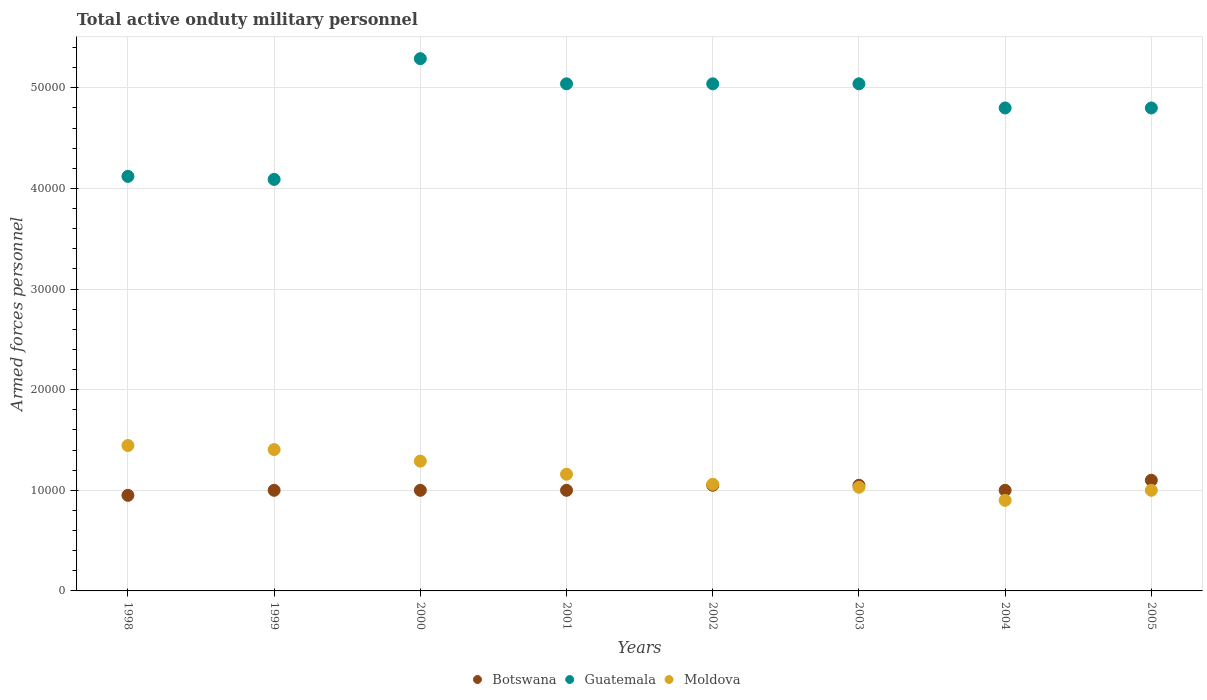What is the number of armed forces personnel in Moldova in 2002?
Your answer should be compact. 1.06e+04. Across all years, what is the maximum number of armed forces personnel in Guatemala?
Make the answer very short. 5.29e+04. Across all years, what is the minimum number of armed forces personnel in Botswana?
Provide a short and direct response. 9500. In which year was the number of armed forces personnel in Moldova maximum?
Provide a short and direct response. 1998. In which year was the number of armed forces personnel in Botswana minimum?
Your answer should be compact. 1998. What is the total number of armed forces personnel in Moldova in the graph?
Keep it short and to the point. 9.29e+04. What is the difference between the number of armed forces personnel in Moldova in 1999 and that in 2002?
Ensure brevity in your answer.  3450. What is the difference between the number of armed forces personnel in Moldova in 1998 and the number of armed forces personnel in Guatemala in 1999?
Provide a succinct answer. -2.64e+04. What is the average number of armed forces personnel in Guatemala per year?
Your response must be concise. 4.78e+04. In how many years, is the number of armed forces personnel in Botswana greater than 6000?
Your answer should be very brief. 8. What is the ratio of the number of armed forces personnel in Moldova in 2001 to that in 2004?
Give a very brief answer. 1.29. What is the difference between the highest and the second highest number of armed forces personnel in Guatemala?
Offer a terse response. 2500. What is the difference between the highest and the lowest number of armed forces personnel in Moldova?
Give a very brief answer. 5450. Is the sum of the number of armed forces personnel in Guatemala in 2003 and 2004 greater than the maximum number of armed forces personnel in Moldova across all years?
Make the answer very short. Yes. Is it the case that in every year, the sum of the number of armed forces personnel in Botswana and number of armed forces personnel in Moldova  is greater than the number of armed forces personnel in Guatemala?
Your answer should be compact. No. Is the number of armed forces personnel in Moldova strictly less than the number of armed forces personnel in Guatemala over the years?
Provide a short and direct response. Yes. How many years are there in the graph?
Offer a very short reply. 8. What is the difference between two consecutive major ticks on the Y-axis?
Your answer should be very brief. 10000. Are the values on the major ticks of Y-axis written in scientific E-notation?
Your answer should be very brief. No. Does the graph contain any zero values?
Ensure brevity in your answer.  No. Does the graph contain grids?
Your answer should be very brief. Yes. Where does the legend appear in the graph?
Your response must be concise. Bottom center. How many legend labels are there?
Your answer should be compact. 3. What is the title of the graph?
Your answer should be very brief. Total active onduty military personnel. Does "Bahamas" appear as one of the legend labels in the graph?
Your answer should be very brief. No. What is the label or title of the X-axis?
Your answer should be compact. Years. What is the label or title of the Y-axis?
Your answer should be compact. Armed forces personnel. What is the Armed forces personnel in Botswana in 1998?
Give a very brief answer. 9500. What is the Armed forces personnel of Guatemala in 1998?
Offer a terse response. 4.12e+04. What is the Armed forces personnel of Moldova in 1998?
Ensure brevity in your answer.  1.44e+04. What is the Armed forces personnel of Botswana in 1999?
Offer a very short reply. 10000. What is the Armed forces personnel in Guatemala in 1999?
Provide a short and direct response. 4.09e+04. What is the Armed forces personnel in Moldova in 1999?
Your response must be concise. 1.40e+04. What is the Armed forces personnel in Botswana in 2000?
Make the answer very short. 10000. What is the Armed forces personnel in Guatemala in 2000?
Make the answer very short. 5.29e+04. What is the Armed forces personnel of Moldova in 2000?
Offer a terse response. 1.29e+04. What is the Armed forces personnel in Guatemala in 2001?
Offer a very short reply. 5.04e+04. What is the Armed forces personnel in Moldova in 2001?
Offer a terse response. 1.16e+04. What is the Armed forces personnel of Botswana in 2002?
Keep it short and to the point. 1.05e+04. What is the Armed forces personnel in Guatemala in 2002?
Make the answer very short. 5.04e+04. What is the Armed forces personnel in Moldova in 2002?
Give a very brief answer. 1.06e+04. What is the Armed forces personnel of Botswana in 2003?
Ensure brevity in your answer.  1.05e+04. What is the Armed forces personnel of Guatemala in 2003?
Make the answer very short. 5.04e+04. What is the Armed forces personnel of Moldova in 2003?
Make the answer very short. 1.03e+04. What is the Armed forces personnel of Botswana in 2004?
Your answer should be compact. 10000. What is the Armed forces personnel of Guatemala in 2004?
Give a very brief answer. 4.80e+04. What is the Armed forces personnel of Moldova in 2004?
Offer a terse response. 9000. What is the Armed forces personnel in Botswana in 2005?
Make the answer very short. 1.10e+04. What is the Armed forces personnel in Guatemala in 2005?
Your response must be concise. 4.80e+04. What is the Armed forces personnel in Moldova in 2005?
Ensure brevity in your answer.  10000. Across all years, what is the maximum Armed forces personnel in Botswana?
Your answer should be compact. 1.10e+04. Across all years, what is the maximum Armed forces personnel in Guatemala?
Keep it short and to the point. 5.29e+04. Across all years, what is the maximum Armed forces personnel of Moldova?
Your answer should be compact. 1.44e+04. Across all years, what is the minimum Armed forces personnel of Botswana?
Provide a succinct answer. 9500. Across all years, what is the minimum Armed forces personnel of Guatemala?
Your answer should be compact. 4.09e+04. Across all years, what is the minimum Armed forces personnel of Moldova?
Ensure brevity in your answer.  9000. What is the total Armed forces personnel of Botswana in the graph?
Provide a short and direct response. 8.15e+04. What is the total Armed forces personnel of Guatemala in the graph?
Your answer should be compact. 3.82e+05. What is the total Armed forces personnel of Moldova in the graph?
Your answer should be very brief. 9.29e+04. What is the difference between the Armed forces personnel in Botswana in 1998 and that in 1999?
Provide a short and direct response. -500. What is the difference between the Armed forces personnel of Guatemala in 1998 and that in 1999?
Offer a terse response. 300. What is the difference between the Armed forces personnel of Moldova in 1998 and that in 1999?
Keep it short and to the point. 400. What is the difference between the Armed forces personnel of Botswana in 1998 and that in 2000?
Offer a very short reply. -500. What is the difference between the Armed forces personnel of Guatemala in 1998 and that in 2000?
Keep it short and to the point. -1.17e+04. What is the difference between the Armed forces personnel of Moldova in 1998 and that in 2000?
Your answer should be compact. 1550. What is the difference between the Armed forces personnel in Botswana in 1998 and that in 2001?
Your response must be concise. -500. What is the difference between the Armed forces personnel in Guatemala in 1998 and that in 2001?
Give a very brief answer. -9200. What is the difference between the Armed forces personnel of Moldova in 1998 and that in 2001?
Offer a terse response. 2850. What is the difference between the Armed forces personnel of Botswana in 1998 and that in 2002?
Provide a short and direct response. -1000. What is the difference between the Armed forces personnel in Guatemala in 1998 and that in 2002?
Your answer should be very brief. -9200. What is the difference between the Armed forces personnel of Moldova in 1998 and that in 2002?
Your answer should be very brief. 3850. What is the difference between the Armed forces personnel of Botswana in 1998 and that in 2003?
Offer a very short reply. -1000. What is the difference between the Armed forces personnel in Guatemala in 1998 and that in 2003?
Offer a very short reply. -9200. What is the difference between the Armed forces personnel in Moldova in 1998 and that in 2003?
Ensure brevity in your answer.  4150. What is the difference between the Armed forces personnel in Botswana in 1998 and that in 2004?
Provide a succinct answer. -500. What is the difference between the Armed forces personnel in Guatemala in 1998 and that in 2004?
Your answer should be very brief. -6800. What is the difference between the Armed forces personnel of Moldova in 1998 and that in 2004?
Keep it short and to the point. 5450. What is the difference between the Armed forces personnel of Botswana in 1998 and that in 2005?
Make the answer very short. -1500. What is the difference between the Armed forces personnel of Guatemala in 1998 and that in 2005?
Make the answer very short. -6800. What is the difference between the Armed forces personnel of Moldova in 1998 and that in 2005?
Your answer should be very brief. 4450. What is the difference between the Armed forces personnel in Guatemala in 1999 and that in 2000?
Give a very brief answer. -1.20e+04. What is the difference between the Armed forces personnel in Moldova in 1999 and that in 2000?
Offer a terse response. 1150. What is the difference between the Armed forces personnel of Guatemala in 1999 and that in 2001?
Your answer should be compact. -9500. What is the difference between the Armed forces personnel of Moldova in 1999 and that in 2001?
Keep it short and to the point. 2450. What is the difference between the Armed forces personnel of Botswana in 1999 and that in 2002?
Provide a short and direct response. -500. What is the difference between the Armed forces personnel of Guatemala in 1999 and that in 2002?
Keep it short and to the point. -9500. What is the difference between the Armed forces personnel of Moldova in 1999 and that in 2002?
Offer a very short reply. 3450. What is the difference between the Armed forces personnel in Botswana in 1999 and that in 2003?
Your answer should be very brief. -500. What is the difference between the Armed forces personnel in Guatemala in 1999 and that in 2003?
Your response must be concise. -9500. What is the difference between the Armed forces personnel of Moldova in 1999 and that in 2003?
Offer a terse response. 3750. What is the difference between the Armed forces personnel of Botswana in 1999 and that in 2004?
Your response must be concise. 0. What is the difference between the Armed forces personnel of Guatemala in 1999 and that in 2004?
Keep it short and to the point. -7100. What is the difference between the Armed forces personnel of Moldova in 1999 and that in 2004?
Your answer should be compact. 5050. What is the difference between the Armed forces personnel of Botswana in 1999 and that in 2005?
Your answer should be very brief. -1000. What is the difference between the Armed forces personnel of Guatemala in 1999 and that in 2005?
Your answer should be compact. -7100. What is the difference between the Armed forces personnel of Moldova in 1999 and that in 2005?
Offer a very short reply. 4050. What is the difference between the Armed forces personnel in Guatemala in 2000 and that in 2001?
Your response must be concise. 2500. What is the difference between the Armed forces personnel of Moldova in 2000 and that in 2001?
Make the answer very short. 1300. What is the difference between the Armed forces personnel of Botswana in 2000 and that in 2002?
Provide a short and direct response. -500. What is the difference between the Armed forces personnel of Guatemala in 2000 and that in 2002?
Your response must be concise. 2500. What is the difference between the Armed forces personnel of Moldova in 2000 and that in 2002?
Give a very brief answer. 2300. What is the difference between the Armed forces personnel in Botswana in 2000 and that in 2003?
Make the answer very short. -500. What is the difference between the Armed forces personnel in Guatemala in 2000 and that in 2003?
Offer a terse response. 2500. What is the difference between the Armed forces personnel in Moldova in 2000 and that in 2003?
Your response must be concise. 2600. What is the difference between the Armed forces personnel of Botswana in 2000 and that in 2004?
Your answer should be very brief. 0. What is the difference between the Armed forces personnel in Guatemala in 2000 and that in 2004?
Give a very brief answer. 4900. What is the difference between the Armed forces personnel in Moldova in 2000 and that in 2004?
Offer a terse response. 3900. What is the difference between the Armed forces personnel of Botswana in 2000 and that in 2005?
Keep it short and to the point. -1000. What is the difference between the Armed forces personnel in Guatemala in 2000 and that in 2005?
Give a very brief answer. 4900. What is the difference between the Armed forces personnel in Moldova in 2000 and that in 2005?
Your answer should be very brief. 2900. What is the difference between the Armed forces personnel in Botswana in 2001 and that in 2002?
Give a very brief answer. -500. What is the difference between the Armed forces personnel in Guatemala in 2001 and that in 2002?
Give a very brief answer. 0. What is the difference between the Armed forces personnel of Moldova in 2001 and that in 2002?
Give a very brief answer. 1000. What is the difference between the Armed forces personnel of Botswana in 2001 and that in 2003?
Your answer should be compact. -500. What is the difference between the Armed forces personnel in Moldova in 2001 and that in 2003?
Your response must be concise. 1300. What is the difference between the Armed forces personnel of Botswana in 2001 and that in 2004?
Your response must be concise. 0. What is the difference between the Armed forces personnel in Guatemala in 2001 and that in 2004?
Give a very brief answer. 2400. What is the difference between the Armed forces personnel in Moldova in 2001 and that in 2004?
Offer a terse response. 2600. What is the difference between the Armed forces personnel of Botswana in 2001 and that in 2005?
Provide a succinct answer. -1000. What is the difference between the Armed forces personnel in Guatemala in 2001 and that in 2005?
Offer a terse response. 2400. What is the difference between the Armed forces personnel in Moldova in 2001 and that in 2005?
Your answer should be very brief. 1600. What is the difference between the Armed forces personnel in Moldova in 2002 and that in 2003?
Provide a short and direct response. 300. What is the difference between the Armed forces personnel of Guatemala in 2002 and that in 2004?
Provide a succinct answer. 2400. What is the difference between the Armed forces personnel in Moldova in 2002 and that in 2004?
Your response must be concise. 1600. What is the difference between the Armed forces personnel of Botswana in 2002 and that in 2005?
Your response must be concise. -500. What is the difference between the Armed forces personnel in Guatemala in 2002 and that in 2005?
Your answer should be compact. 2400. What is the difference between the Armed forces personnel of Moldova in 2002 and that in 2005?
Ensure brevity in your answer.  600. What is the difference between the Armed forces personnel in Guatemala in 2003 and that in 2004?
Offer a terse response. 2400. What is the difference between the Armed forces personnel of Moldova in 2003 and that in 2004?
Provide a succinct answer. 1300. What is the difference between the Armed forces personnel in Botswana in 2003 and that in 2005?
Your answer should be very brief. -500. What is the difference between the Armed forces personnel in Guatemala in 2003 and that in 2005?
Your answer should be compact. 2400. What is the difference between the Armed forces personnel of Moldova in 2003 and that in 2005?
Your answer should be very brief. 300. What is the difference between the Armed forces personnel of Botswana in 2004 and that in 2005?
Give a very brief answer. -1000. What is the difference between the Armed forces personnel in Moldova in 2004 and that in 2005?
Keep it short and to the point. -1000. What is the difference between the Armed forces personnel in Botswana in 1998 and the Armed forces personnel in Guatemala in 1999?
Your answer should be very brief. -3.14e+04. What is the difference between the Armed forces personnel of Botswana in 1998 and the Armed forces personnel of Moldova in 1999?
Give a very brief answer. -4550. What is the difference between the Armed forces personnel of Guatemala in 1998 and the Armed forces personnel of Moldova in 1999?
Make the answer very short. 2.72e+04. What is the difference between the Armed forces personnel in Botswana in 1998 and the Armed forces personnel in Guatemala in 2000?
Your answer should be very brief. -4.34e+04. What is the difference between the Armed forces personnel of Botswana in 1998 and the Armed forces personnel of Moldova in 2000?
Keep it short and to the point. -3400. What is the difference between the Armed forces personnel in Guatemala in 1998 and the Armed forces personnel in Moldova in 2000?
Give a very brief answer. 2.83e+04. What is the difference between the Armed forces personnel in Botswana in 1998 and the Armed forces personnel in Guatemala in 2001?
Ensure brevity in your answer.  -4.09e+04. What is the difference between the Armed forces personnel in Botswana in 1998 and the Armed forces personnel in Moldova in 2001?
Offer a terse response. -2100. What is the difference between the Armed forces personnel of Guatemala in 1998 and the Armed forces personnel of Moldova in 2001?
Your response must be concise. 2.96e+04. What is the difference between the Armed forces personnel in Botswana in 1998 and the Armed forces personnel in Guatemala in 2002?
Make the answer very short. -4.09e+04. What is the difference between the Armed forces personnel in Botswana in 1998 and the Armed forces personnel in Moldova in 2002?
Offer a very short reply. -1100. What is the difference between the Armed forces personnel of Guatemala in 1998 and the Armed forces personnel of Moldova in 2002?
Provide a short and direct response. 3.06e+04. What is the difference between the Armed forces personnel in Botswana in 1998 and the Armed forces personnel in Guatemala in 2003?
Give a very brief answer. -4.09e+04. What is the difference between the Armed forces personnel in Botswana in 1998 and the Armed forces personnel in Moldova in 2003?
Ensure brevity in your answer.  -800. What is the difference between the Armed forces personnel in Guatemala in 1998 and the Armed forces personnel in Moldova in 2003?
Your response must be concise. 3.09e+04. What is the difference between the Armed forces personnel in Botswana in 1998 and the Armed forces personnel in Guatemala in 2004?
Provide a succinct answer. -3.85e+04. What is the difference between the Armed forces personnel of Guatemala in 1998 and the Armed forces personnel of Moldova in 2004?
Provide a succinct answer. 3.22e+04. What is the difference between the Armed forces personnel of Botswana in 1998 and the Armed forces personnel of Guatemala in 2005?
Your answer should be compact. -3.85e+04. What is the difference between the Armed forces personnel in Botswana in 1998 and the Armed forces personnel in Moldova in 2005?
Make the answer very short. -500. What is the difference between the Armed forces personnel in Guatemala in 1998 and the Armed forces personnel in Moldova in 2005?
Make the answer very short. 3.12e+04. What is the difference between the Armed forces personnel of Botswana in 1999 and the Armed forces personnel of Guatemala in 2000?
Your response must be concise. -4.29e+04. What is the difference between the Armed forces personnel of Botswana in 1999 and the Armed forces personnel of Moldova in 2000?
Make the answer very short. -2900. What is the difference between the Armed forces personnel in Guatemala in 1999 and the Armed forces personnel in Moldova in 2000?
Offer a very short reply. 2.80e+04. What is the difference between the Armed forces personnel in Botswana in 1999 and the Armed forces personnel in Guatemala in 2001?
Your response must be concise. -4.04e+04. What is the difference between the Armed forces personnel of Botswana in 1999 and the Armed forces personnel of Moldova in 2001?
Your response must be concise. -1600. What is the difference between the Armed forces personnel of Guatemala in 1999 and the Armed forces personnel of Moldova in 2001?
Offer a terse response. 2.93e+04. What is the difference between the Armed forces personnel in Botswana in 1999 and the Armed forces personnel in Guatemala in 2002?
Your answer should be very brief. -4.04e+04. What is the difference between the Armed forces personnel in Botswana in 1999 and the Armed forces personnel in Moldova in 2002?
Your answer should be very brief. -600. What is the difference between the Armed forces personnel in Guatemala in 1999 and the Armed forces personnel in Moldova in 2002?
Provide a short and direct response. 3.03e+04. What is the difference between the Armed forces personnel in Botswana in 1999 and the Armed forces personnel in Guatemala in 2003?
Offer a very short reply. -4.04e+04. What is the difference between the Armed forces personnel in Botswana in 1999 and the Armed forces personnel in Moldova in 2003?
Your answer should be compact. -300. What is the difference between the Armed forces personnel in Guatemala in 1999 and the Armed forces personnel in Moldova in 2003?
Provide a succinct answer. 3.06e+04. What is the difference between the Armed forces personnel of Botswana in 1999 and the Armed forces personnel of Guatemala in 2004?
Your answer should be compact. -3.80e+04. What is the difference between the Armed forces personnel in Guatemala in 1999 and the Armed forces personnel in Moldova in 2004?
Offer a terse response. 3.19e+04. What is the difference between the Armed forces personnel of Botswana in 1999 and the Armed forces personnel of Guatemala in 2005?
Your response must be concise. -3.80e+04. What is the difference between the Armed forces personnel of Botswana in 1999 and the Armed forces personnel of Moldova in 2005?
Make the answer very short. 0. What is the difference between the Armed forces personnel of Guatemala in 1999 and the Armed forces personnel of Moldova in 2005?
Your answer should be compact. 3.09e+04. What is the difference between the Armed forces personnel of Botswana in 2000 and the Armed forces personnel of Guatemala in 2001?
Provide a succinct answer. -4.04e+04. What is the difference between the Armed forces personnel in Botswana in 2000 and the Armed forces personnel in Moldova in 2001?
Keep it short and to the point. -1600. What is the difference between the Armed forces personnel in Guatemala in 2000 and the Armed forces personnel in Moldova in 2001?
Your answer should be compact. 4.13e+04. What is the difference between the Armed forces personnel in Botswana in 2000 and the Armed forces personnel in Guatemala in 2002?
Provide a short and direct response. -4.04e+04. What is the difference between the Armed forces personnel of Botswana in 2000 and the Armed forces personnel of Moldova in 2002?
Your answer should be very brief. -600. What is the difference between the Armed forces personnel in Guatemala in 2000 and the Armed forces personnel in Moldova in 2002?
Ensure brevity in your answer.  4.23e+04. What is the difference between the Armed forces personnel in Botswana in 2000 and the Armed forces personnel in Guatemala in 2003?
Your answer should be compact. -4.04e+04. What is the difference between the Armed forces personnel in Botswana in 2000 and the Armed forces personnel in Moldova in 2003?
Your answer should be compact. -300. What is the difference between the Armed forces personnel in Guatemala in 2000 and the Armed forces personnel in Moldova in 2003?
Make the answer very short. 4.26e+04. What is the difference between the Armed forces personnel of Botswana in 2000 and the Armed forces personnel of Guatemala in 2004?
Offer a very short reply. -3.80e+04. What is the difference between the Armed forces personnel of Guatemala in 2000 and the Armed forces personnel of Moldova in 2004?
Your response must be concise. 4.39e+04. What is the difference between the Armed forces personnel of Botswana in 2000 and the Armed forces personnel of Guatemala in 2005?
Provide a short and direct response. -3.80e+04. What is the difference between the Armed forces personnel of Guatemala in 2000 and the Armed forces personnel of Moldova in 2005?
Ensure brevity in your answer.  4.29e+04. What is the difference between the Armed forces personnel of Botswana in 2001 and the Armed forces personnel of Guatemala in 2002?
Offer a very short reply. -4.04e+04. What is the difference between the Armed forces personnel in Botswana in 2001 and the Armed forces personnel in Moldova in 2002?
Provide a short and direct response. -600. What is the difference between the Armed forces personnel in Guatemala in 2001 and the Armed forces personnel in Moldova in 2002?
Give a very brief answer. 3.98e+04. What is the difference between the Armed forces personnel in Botswana in 2001 and the Armed forces personnel in Guatemala in 2003?
Provide a succinct answer. -4.04e+04. What is the difference between the Armed forces personnel of Botswana in 2001 and the Armed forces personnel of Moldova in 2003?
Ensure brevity in your answer.  -300. What is the difference between the Armed forces personnel in Guatemala in 2001 and the Armed forces personnel in Moldova in 2003?
Ensure brevity in your answer.  4.01e+04. What is the difference between the Armed forces personnel in Botswana in 2001 and the Armed forces personnel in Guatemala in 2004?
Offer a terse response. -3.80e+04. What is the difference between the Armed forces personnel in Botswana in 2001 and the Armed forces personnel in Moldova in 2004?
Your answer should be compact. 1000. What is the difference between the Armed forces personnel of Guatemala in 2001 and the Armed forces personnel of Moldova in 2004?
Keep it short and to the point. 4.14e+04. What is the difference between the Armed forces personnel in Botswana in 2001 and the Armed forces personnel in Guatemala in 2005?
Your answer should be very brief. -3.80e+04. What is the difference between the Armed forces personnel of Guatemala in 2001 and the Armed forces personnel of Moldova in 2005?
Your answer should be very brief. 4.04e+04. What is the difference between the Armed forces personnel of Botswana in 2002 and the Armed forces personnel of Guatemala in 2003?
Provide a short and direct response. -3.99e+04. What is the difference between the Armed forces personnel of Guatemala in 2002 and the Armed forces personnel of Moldova in 2003?
Your answer should be very brief. 4.01e+04. What is the difference between the Armed forces personnel in Botswana in 2002 and the Armed forces personnel in Guatemala in 2004?
Keep it short and to the point. -3.75e+04. What is the difference between the Armed forces personnel of Botswana in 2002 and the Armed forces personnel of Moldova in 2004?
Your response must be concise. 1500. What is the difference between the Armed forces personnel in Guatemala in 2002 and the Armed forces personnel in Moldova in 2004?
Offer a very short reply. 4.14e+04. What is the difference between the Armed forces personnel in Botswana in 2002 and the Armed forces personnel in Guatemala in 2005?
Provide a succinct answer. -3.75e+04. What is the difference between the Armed forces personnel of Guatemala in 2002 and the Armed forces personnel of Moldova in 2005?
Make the answer very short. 4.04e+04. What is the difference between the Armed forces personnel in Botswana in 2003 and the Armed forces personnel in Guatemala in 2004?
Ensure brevity in your answer.  -3.75e+04. What is the difference between the Armed forces personnel of Botswana in 2003 and the Armed forces personnel of Moldova in 2004?
Offer a very short reply. 1500. What is the difference between the Armed forces personnel in Guatemala in 2003 and the Armed forces personnel in Moldova in 2004?
Provide a short and direct response. 4.14e+04. What is the difference between the Armed forces personnel in Botswana in 2003 and the Armed forces personnel in Guatemala in 2005?
Your response must be concise. -3.75e+04. What is the difference between the Armed forces personnel of Botswana in 2003 and the Armed forces personnel of Moldova in 2005?
Keep it short and to the point. 500. What is the difference between the Armed forces personnel in Guatemala in 2003 and the Armed forces personnel in Moldova in 2005?
Provide a succinct answer. 4.04e+04. What is the difference between the Armed forces personnel of Botswana in 2004 and the Armed forces personnel of Guatemala in 2005?
Your answer should be very brief. -3.80e+04. What is the difference between the Armed forces personnel in Guatemala in 2004 and the Armed forces personnel in Moldova in 2005?
Keep it short and to the point. 3.80e+04. What is the average Armed forces personnel of Botswana per year?
Offer a terse response. 1.02e+04. What is the average Armed forces personnel of Guatemala per year?
Your response must be concise. 4.78e+04. What is the average Armed forces personnel in Moldova per year?
Ensure brevity in your answer.  1.16e+04. In the year 1998, what is the difference between the Armed forces personnel in Botswana and Armed forces personnel in Guatemala?
Make the answer very short. -3.17e+04. In the year 1998, what is the difference between the Armed forces personnel in Botswana and Armed forces personnel in Moldova?
Provide a succinct answer. -4950. In the year 1998, what is the difference between the Armed forces personnel in Guatemala and Armed forces personnel in Moldova?
Offer a terse response. 2.68e+04. In the year 1999, what is the difference between the Armed forces personnel of Botswana and Armed forces personnel of Guatemala?
Keep it short and to the point. -3.09e+04. In the year 1999, what is the difference between the Armed forces personnel in Botswana and Armed forces personnel in Moldova?
Make the answer very short. -4050. In the year 1999, what is the difference between the Armed forces personnel in Guatemala and Armed forces personnel in Moldova?
Provide a short and direct response. 2.68e+04. In the year 2000, what is the difference between the Armed forces personnel in Botswana and Armed forces personnel in Guatemala?
Your response must be concise. -4.29e+04. In the year 2000, what is the difference between the Armed forces personnel of Botswana and Armed forces personnel of Moldova?
Your answer should be very brief. -2900. In the year 2000, what is the difference between the Armed forces personnel in Guatemala and Armed forces personnel in Moldova?
Your answer should be compact. 4.00e+04. In the year 2001, what is the difference between the Armed forces personnel of Botswana and Armed forces personnel of Guatemala?
Offer a very short reply. -4.04e+04. In the year 2001, what is the difference between the Armed forces personnel in Botswana and Armed forces personnel in Moldova?
Provide a succinct answer. -1600. In the year 2001, what is the difference between the Armed forces personnel in Guatemala and Armed forces personnel in Moldova?
Your answer should be very brief. 3.88e+04. In the year 2002, what is the difference between the Armed forces personnel in Botswana and Armed forces personnel in Guatemala?
Give a very brief answer. -3.99e+04. In the year 2002, what is the difference between the Armed forces personnel of Botswana and Armed forces personnel of Moldova?
Make the answer very short. -100. In the year 2002, what is the difference between the Armed forces personnel of Guatemala and Armed forces personnel of Moldova?
Keep it short and to the point. 3.98e+04. In the year 2003, what is the difference between the Armed forces personnel in Botswana and Armed forces personnel in Guatemala?
Keep it short and to the point. -3.99e+04. In the year 2003, what is the difference between the Armed forces personnel of Guatemala and Armed forces personnel of Moldova?
Ensure brevity in your answer.  4.01e+04. In the year 2004, what is the difference between the Armed forces personnel in Botswana and Armed forces personnel in Guatemala?
Make the answer very short. -3.80e+04. In the year 2004, what is the difference between the Armed forces personnel in Guatemala and Armed forces personnel in Moldova?
Give a very brief answer. 3.90e+04. In the year 2005, what is the difference between the Armed forces personnel in Botswana and Armed forces personnel in Guatemala?
Your response must be concise. -3.70e+04. In the year 2005, what is the difference between the Armed forces personnel of Guatemala and Armed forces personnel of Moldova?
Your response must be concise. 3.80e+04. What is the ratio of the Armed forces personnel in Botswana in 1998 to that in 1999?
Offer a very short reply. 0.95. What is the ratio of the Armed forces personnel in Guatemala in 1998 to that in 1999?
Keep it short and to the point. 1.01. What is the ratio of the Armed forces personnel in Moldova in 1998 to that in 1999?
Offer a terse response. 1.03. What is the ratio of the Armed forces personnel of Botswana in 1998 to that in 2000?
Offer a very short reply. 0.95. What is the ratio of the Armed forces personnel of Guatemala in 1998 to that in 2000?
Your response must be concise. 0.78. What is the ratio of the Armed forces personnel of Moldova in 1998 to that in 2000?
Offer a terse response. 1.12. What is the ratio of the Armed forces personnel in Guatemala in 1998 to that in 2001?
Offer a very short reply. 0.82. What is the ratio of the Armed forces personnel in Moldova in 1998 to that in 2001?
Your answer should be very brief. 1.25. What is the ratio of the Armed forces personnel in Botswana in 1998 to that in 2002?
Your answer should be compact. 0.9. What is the ratio of the Armed forces personnel in Guatemala in 1998 to that in 2002?
Your answer should be very brief. 0.82. What is the ratio of the Armed forces personnel of Moldova in 1998 to that in 2002?
Provide a succinct answer. 1.36. What is the ratio of the Armed forces personnel of Botswana in 1998 to that in 2003?
Make the answer very short. 0.9. What is the ratio of the Armed forces personnel of Guatemala in 1998 to that in 2003?
Keep it short and to the point. 0.82. What is the ratio of the Armed forces personnel of Moldova in 1998 to that in 2003?
Keep it short and to the point. 1.4. What is the ratio of the Armed forces personnel in Botswana in 1998 to that in 2004?
Make the answer very short. 0.95. What is the ratio of the Armed forces personnel in Guatemala in 1998 to that in 2004?
Your response must be concise. 0.86. What is the ratio of the Armed forces personnel of Moldova in 1998 to that in 2004?
Keep it short and to the point. 1.61. What is the ratio of the Armed forces personnel in Botswana in 1998 to that in 2005?
Offer a terse response. 0.86. What is the ratio of the Armed forces personnel in Guatemala in 1998 to that in 2005?
Your answer should be compact. 0.86. What is the ratio of the Armed forces personnel in Moldova in 1998 to that in 2005?
Give a very brief answer. 1.45. What is the ratio of the Armed forces personnel in Guatemala in 1999 to that in 2000?
Offer a terse response. 0.77. What is the ratio of the Armed forces personnel of Moldova in 1999 to that in 2000?
Provide a succinct answer. 1.09. What is the ratio of the Armed forces personnel in Botswana in 1999 to that in 2001?
Keep it short and to the point. 1. What is the ratio of the Armed forces personnel in Guatemala in 1999 to that in 2001?
Keep it short and to the point. 0.81. What is the ratio of the Armed forces personnel in Moldova in 1999 to that in 2001?
Offer a terse response. 1.21. What is the ratio of the Armed forces personnel of Guatemala in 1999 to that in 2002?
Your answer should be compact. 0.81. What is the ratio of the Armed forces personnel of Moldova in 1999 to that in 2002?
Your answer should be very brief. 1.33. What is the ratio of the Armed forces personnel in Botswana in 1999 to that in 2003?
Your answer should be compact. 0.95. What is the ratio of the Armed forces personnel in Guatemala in 1999 to that in 2003?
Your response must be concise. 0.81. What is the ratio of the Armed forces personnel in Moldova in 1999 to that in 2003?
Your response must be concise. 1.36. What is the ratio of the Armed forces personnel of Botswana in 1999 to that in 2004?
Provide a short and direct response. 1. What is the ratio of the Armed forces personnel in Guatemala in 1999 to that in 2004?
Your response must be concise. 0.85. What is the ratio of the Armed forces personnel in Moldova in 1999 to that in 2004?
Provide a succinct answer. 1.56. What is the ratio of the Armed forces personnel of Botswana in 1999 to that in 2005?
Make the answer very short. 0.91. What is the ratio of the Armed forces personnel in Guatemala in 1999 to that in 2005?
Make the answer very short. 0.85. What is the ratio of the Armed forces personnel of Moldova in 1999 to that in 2005?
Your answer should be compact. 1.41. What is the ratio of the Armed forces personnel in Botswana in 2000 to that in 2001?
Provide a short and direct response. 1. What is the ratio of the Armed forces personnel in Guatemala in 2000 to that in 2001?
Ensure brevity in your answer.  1.05. What is the ratio of the Armed forces personnel of Moldova in 2000 to that in 2001?
Ensure brevity in your answer.  1.11. What is the ratio of the Armed forces personnel of Botswana in 2000 to that in 2002?
Make the answer very short. 0.95. What is the ratio of the Armed forces personnel in Guatemala in 2000 to that in 2002?
Give a very brief answer. 1.05. What is the ratio of the Armed forces personnel of Moldova in 2000 to that in 2002?
Make the answer very short. 1.22. What is the ratio of the Armed forces personnel in Botswana in 2000 to that in 2003?
Provide a short and direct response. 0.95. What is the ratio of the Armed forces personnel of Guatemala in 2000 to that in 2003?
Provide a short and direct response. 1.05. What is the ratio of the Armed forces personnel in Moldova in 2000 to that in 2003?
Keep it short and to the point. 1.25. What is the ratio of the Armed forces personnel in Guatemala in 2000 to that in 2004?
Your answer should be compact. 1.1. What is the ratio of the Armed forces personnel of Moldova in 2000 to that in 2004?
Keep it short and to the point. 1.43. What is the ratio of the Armed forces personnel in Guatemala in 2000 to that in 2005?
Provide a succinct answer. 1.1. What is the ratio of the Armed forces personnel of Moldova in 2000 to that in 2005?
Your answer should be compact. 1.29. What is the ratio of the Armed forces personnel of Botswana in 2001 to that in 2002?
Offer a terse response. 0.95. What is the ratio of the Armed forces personnel of Guatemala in 2001 to that in 2002?
Offer a terse response. 1. What is the ratio of the Armed forces personnel of Moldova in 2001 to that in 2002?
Make the answer very short. 1.09. What is the ratio of the Armed forces personnel of Moldova in 2001 to that in 2003?
Provide a succinct answer. 1.13. What is the ratio of the Armed forces personnel of Botswana in 2001 to that in 2004?
Provide a short and direct response. 1. What is the ratio of the Armed forces personnel of Guatemala in 2001 to that in 2004?
Your answer should be compact. 1.05. What is the ratio of the Armed forces personnel of Moldova in 2001 to that in 2004?
Keep it short and to the point. 1.29. What is the ratio of the Armed forces personnel of Botswana in 2001 to that in 2005?
Give a very brief answer. 0.91. What is the ratio of the Armed forces personnel of Guatemala in 2001 to that in 2005?
Ensure brevity in your answer.  1.05. What is the ratio of the Armed forces personnel in Moldova in 2001 to that in 2005?
Provide a short and direct response. 1.16. What is the ratio of the Armed forces personnel in Botswana in 2002 to that in 2003?
Offer a very short reply. 1. What is the ratio of the Armed forces personnel of Moldova in 2002 to that in 2003?
Keep it short and to the point. 1.03. What is the ratio of the Armed forces personnel of Guatemala in 2002 to that in 2004?
Keep it short and to the point. 1.05. What is the ratio of the Armed forces personnel of Moldova in 2002 to that in 2004?
Give a very brief answer. 1.18. What is the ratio of the Armed forces personnel of Botswana in 2002 to that in 2005?
Ensure brevity in your answer.  0.95. What is the ratio of the Armed forces personnel in Moldova in 2002 to that in 2005?
Offer a terse response. 1.06. What is the ratio of the Armed forces personnel in Moldova in 2003 to that in 2004?
Give a very brief answer. 1.14. What is the ratio of the Armed forces personnel in Botswana in 2003 to that in 2005?
Offer a terse response. 0.95. What is the ratio of the Armed forces personnel of Guatemala in 2003 to that in 2005?
Provide a short and direct response. 1.05. What is the ratio of the Armed forces personnel of Moldova in 2003 to that in 2005?
Your response must be concise. 1.03. What is the ratio of the Armed forces personnel of Guatemala in 2004 to that in 2005?
Your response must be concise. 1. What is the difference between the highest and the second highest Armed forces personnel in Guatemala?
Your answer should be very brief. 2500. What is the difference between the highest and the lowest Armed forces personnel in Botswana?
Keep it short and to the point. 1500. What is the difference between the highest and the lowest Armed forces personnel in Guatemala?
Your answer should be compact. 1.20e+04. What is the difference between the highest and the lowest Armed forces personnel of Moldova?
Your response must be concise. 5450. 